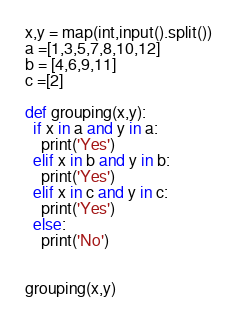<code> <loc_0><loc_0><loc_500><loc_500><_Python_>x,y = map(int,input().split())
a =[1,3,5,7,8,10,12]
b = [4,6,9,11]
c =[2]

def grouping(x,y):
  if x in a and y in a:
    print('Yes')
  elif x in b and y in b:
    print('Yes')
  elif x in c and y in c:
    print('Yes')
  else:
    print('No')


grouping(x,y)

</code> 